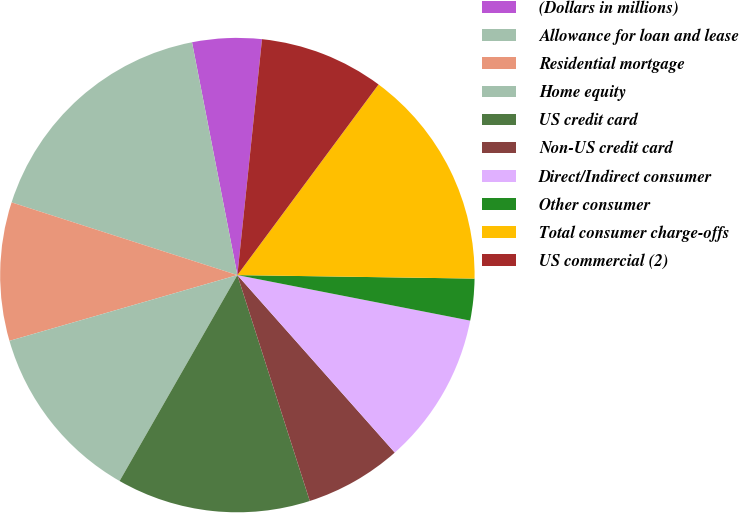<chart> <loc_0><loc_0><loc_500><loc_500><pie_chart><fcel>(Dollars in millions)<fcel>Allowance for loan and lease<fcel>Residential mortgage<fcel>Home equity<fcel>US credit card<fcel>Non-US credit card<fcel>Direct/Indirect consumer<fcel>Other consumer<fcel>Total consumer charge-offs<fcel>US commercial (2)<nl><fcel>4.72%<fcel>16.98%<fcel>9.43%<fcel>12.26%<fcel>13.21%<fcel>6.61%<fcel>10.38%<fcel>2.84%<fcel>15.09%<fcel>8.49%<nl></chart> 